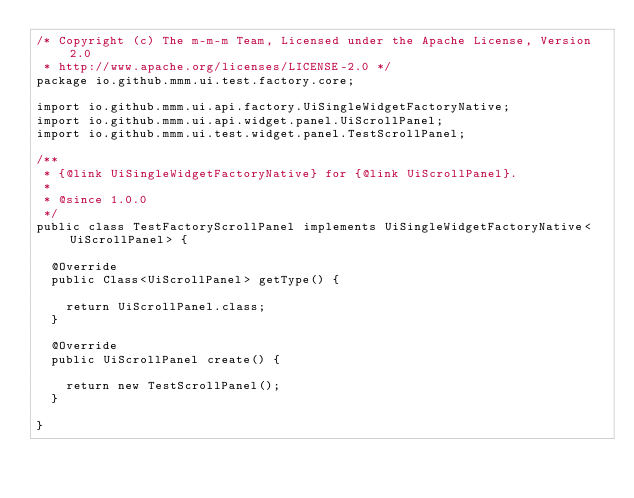Convert code to text. <code><loc_0><loc_0><loc_500><loc_500><_Java_>/* Copyright (c) The m-m-m Team, Licensed under the Apache License, Version 2.0
 * http://www.apache.org/licenses/LICENSE-2.0 */
package io.github.mmm.ui.test.factory.core;

import io.github.mmm.ui.api.factory.UiSingleWidgetFactoryNative;
import io.github.mmm.ui.api.widget.panel.UiScrollPanel;
import io.github.mmm.ui.test.widget.panel.TestScrollPanel;

/**
 * {@link UiSingleWidgetFactoryNative} for {@link UiScrollPanel}.
 *
 * @since 1.0.0
 */
public class TestFactoryScrollPanel implements UiSingleWidgetFactoryNative<UiScrollPanel> {

  @Override
  public Class<UiScrollPanel> getType() {

    return UiScrollPanel.class;
  }

  @Override
  public UiScrollPanel create() {

    return new TestScrollPanel();
  }

}
</code> 